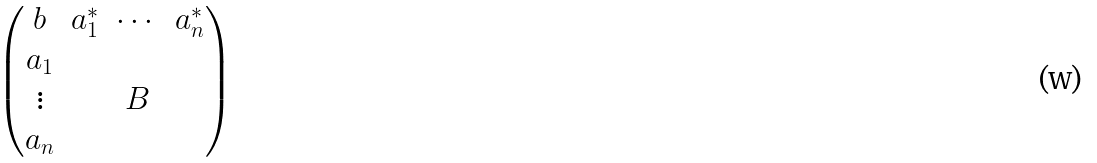<formula> <loc_0><loc_0><loc_500><loc_500>\begin{pmatrix} b & a ^ { * } _ { 1 } & \cdots & a ^ { * } _ { n } \\ a _ { 1 } & & & \\ \vdots & & B & \\ a _ { n } & & & \end{pmatrix}</formula> 